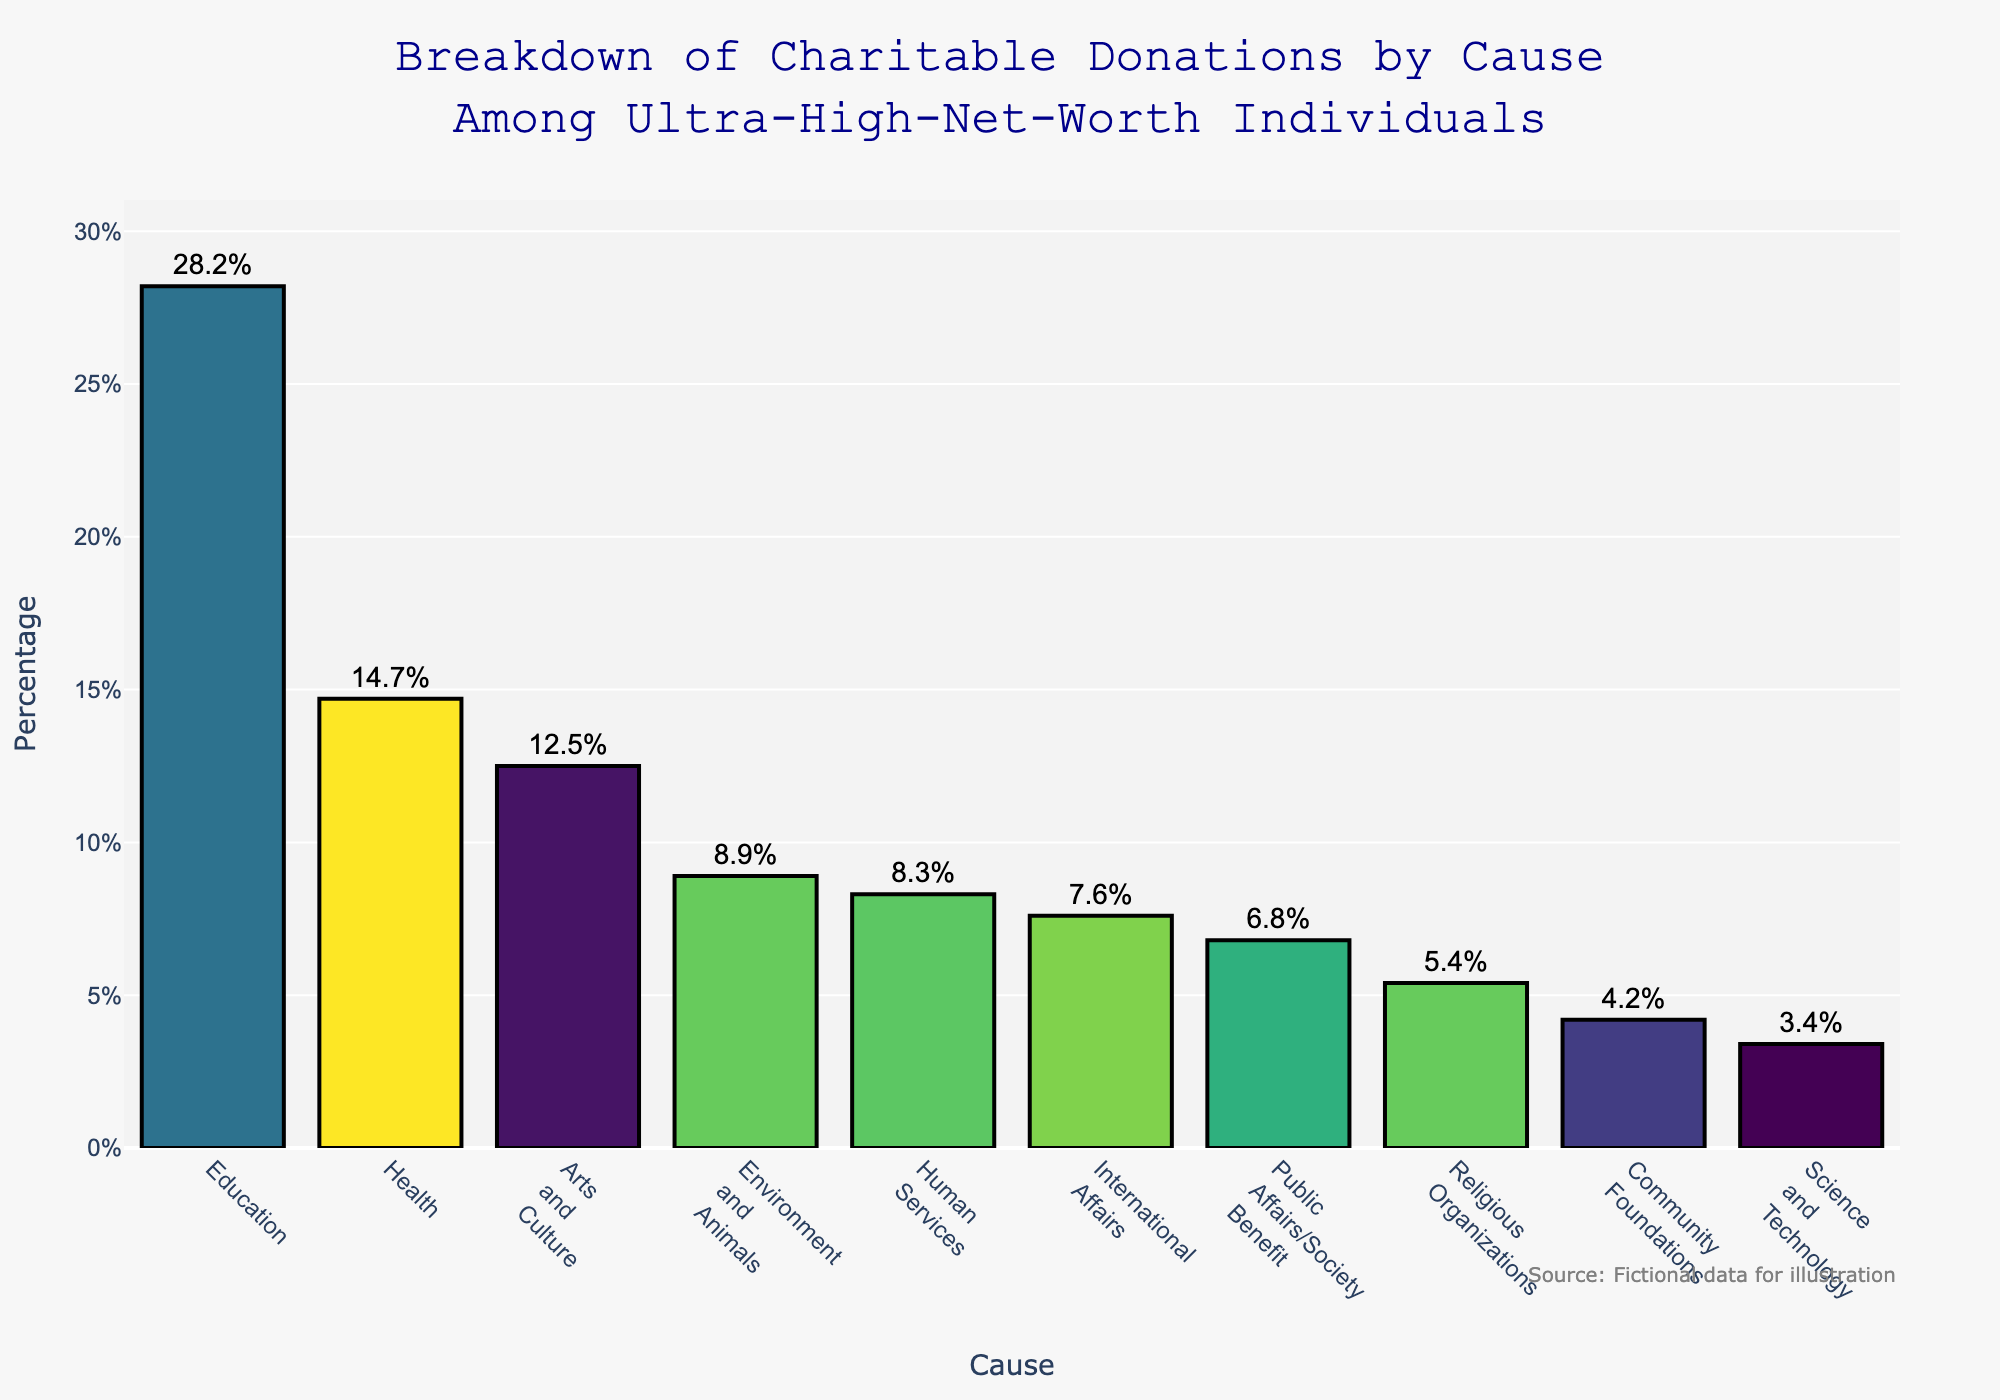Which cause receives the highest percentage of donations? The cause with the highest bar height in the chart represents the largest percentage of donations. Here, Education has the tallest bar with a percentage of 28.2%.
Answer: Education What is the combined percentage of donations going to Health and Science and Technology? To find the combined percentage, add the individual percentages of Health and Science and Technology, which are 14.7% and 3.4% respectively (14.7 + 3.4 = 18.1).
Answer: 18.1% How much more does Education receive compared to Public Affairs/Society Benefit? Subtract the percentage of Public Affairs/Society Benefit (6.8%) from the percentage of Education (28.2%) (28.2 - 6.8 = 21.4).
Answer: 21.4% Which three causes receive the least donations? Identify the three causes with the shortest bars. Here, Science and Technology (3.4%), Community Foundations (4.2%), and Religious Organizations (5.4%) receive the least donations.
Answer: Science and Technology, Community Foundations, Religious Organizations By how many percentage points does Arts and Culture exceed Environment and Animals? Subtract the percentage of Environment and Animals (8.9%) from the percentage of Arts and Culture (12.5%) (12.5 - 8.9 = 3.6).
Answer: 3.6 What percentage of donations goes to causes other than Education? Subtract the percentage of Education (28.2%) from 100% to find the remaining percentage allocated to other causes (100 - 28.2 = 71.8).
Answer: 71.8% Is the percentage donation to Human Services larger than to International Affairs? If so, by how much? Compare the percentages of Human Services (8.3%) and International Affairs (7.6%). Human Services has a higher percentage, so subtract International Affairs' percentage from Human Services' (8.3 - 7.6 = 0.7).
Answer: Yes, by 0.7% What is the average percentage donation for the causes listed? Sum all the percentages and then divide by the number of causes (10). (28.2 + 14.7 + 12.5 + 8.9 + 8.3 + 7.6 + 6.8 + 5.4 + 4.2 + 3.4 = 100; 100 / 10 = 10).
Answer: 10% How do donations to Environment and Animals compare visually to those to Arts and Culture? Look at the height of the bars for Environment and Animals (8.9%) and Arts and Culture (12.5%). The bar for Arts and Culture is clearly taller than the bar for Environment and Animals.
Answer: Arts and Culture is taller What's the difference in percentage points between the highest and the lowest donation causes? Identify the highest (Education, 28.2%) and the lowest (Science and Technology, 3.4%), then subtract the lowest from the highest (28.2 - 3.4 = 24.8).
Answer: 24.8% 